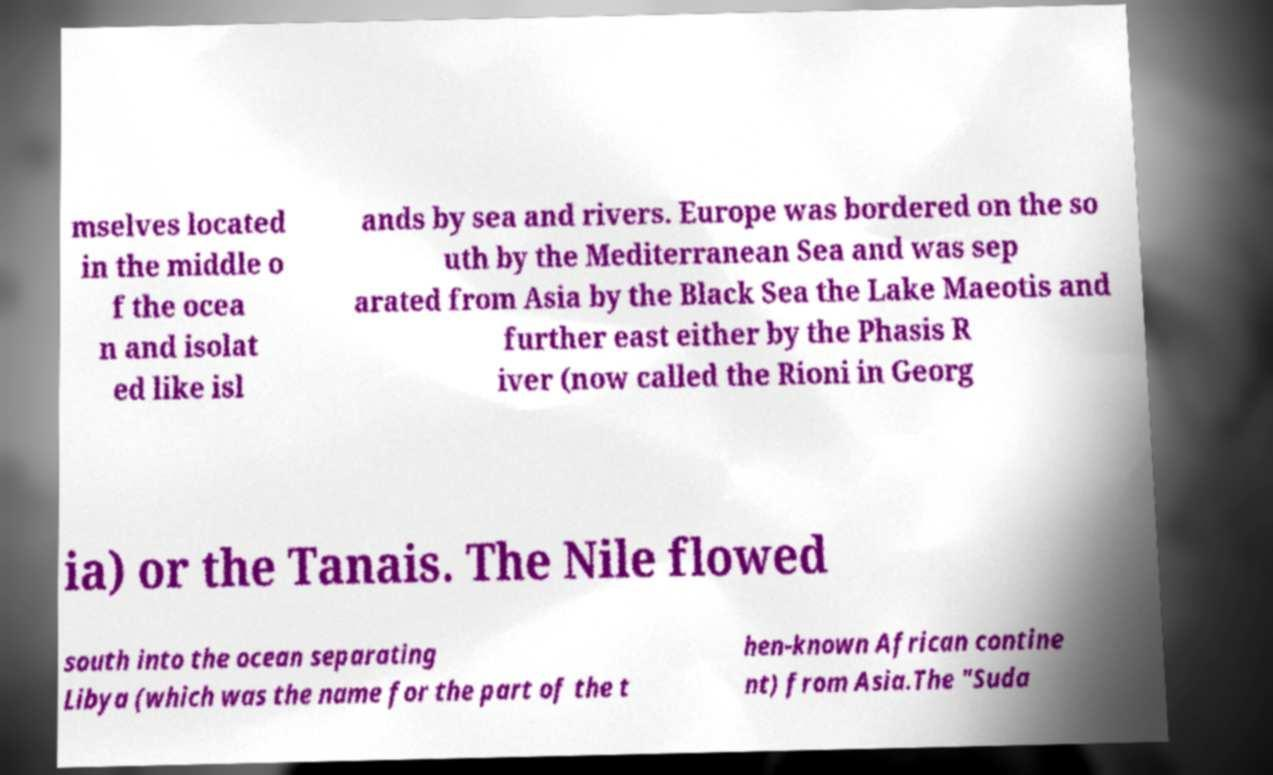Can you read and provide the text displayed in the image?This photo seems to have some interesting text. Can you extract and type it out for me? mselves located in the middle o f the ocea n and isolat ed like isl ands by sea and rivers. Europe was bordered on the so uth by the Mediterranean Sea and was sep arated from Asia by the Black Sea the Lake Maeotis and further east either by the Phasis R iver (now called the Rioni in Georg ia) or the Tanais. The Nile flowed south into the ocean separating Libya (which was the name for the part of the t hen-known African contine nt) from Asia.The "Suda 